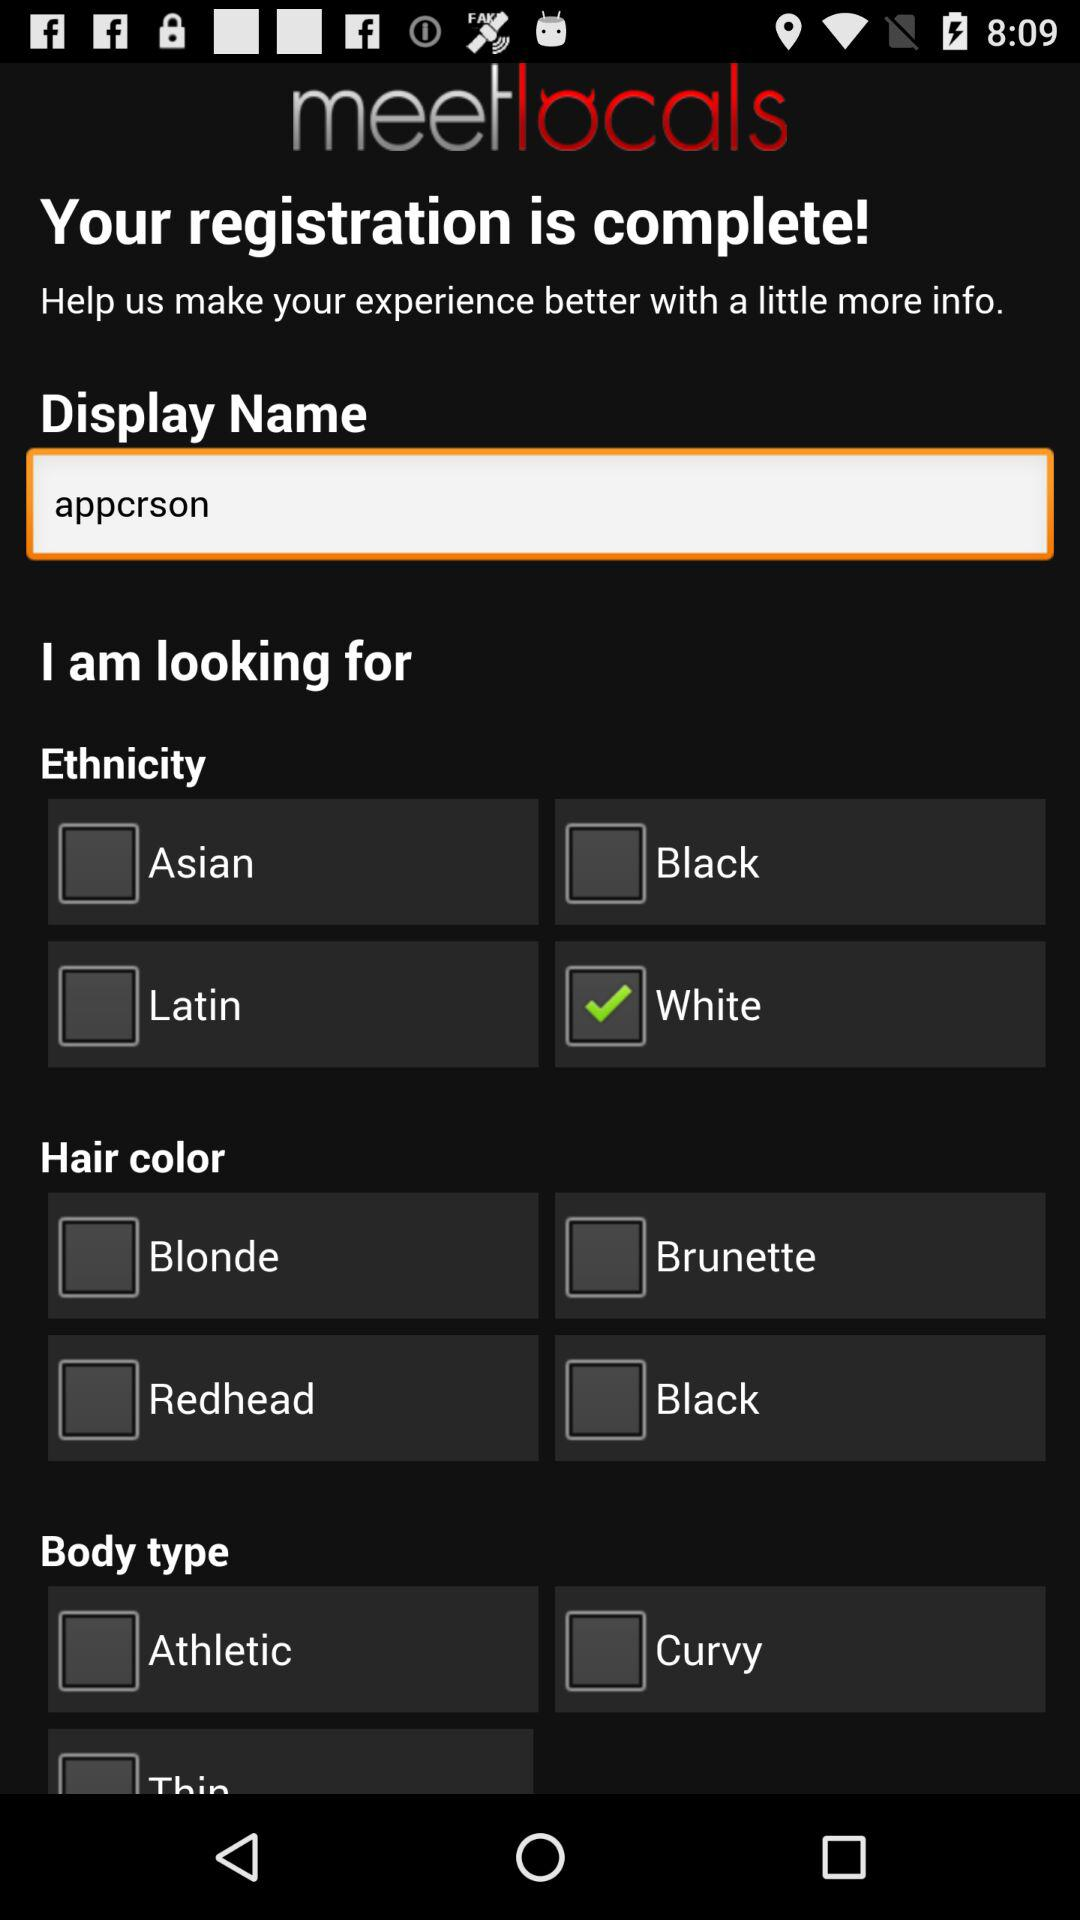What is the selected option in "Ethnicity"? The selected option in "Ethnicity" is "White". 